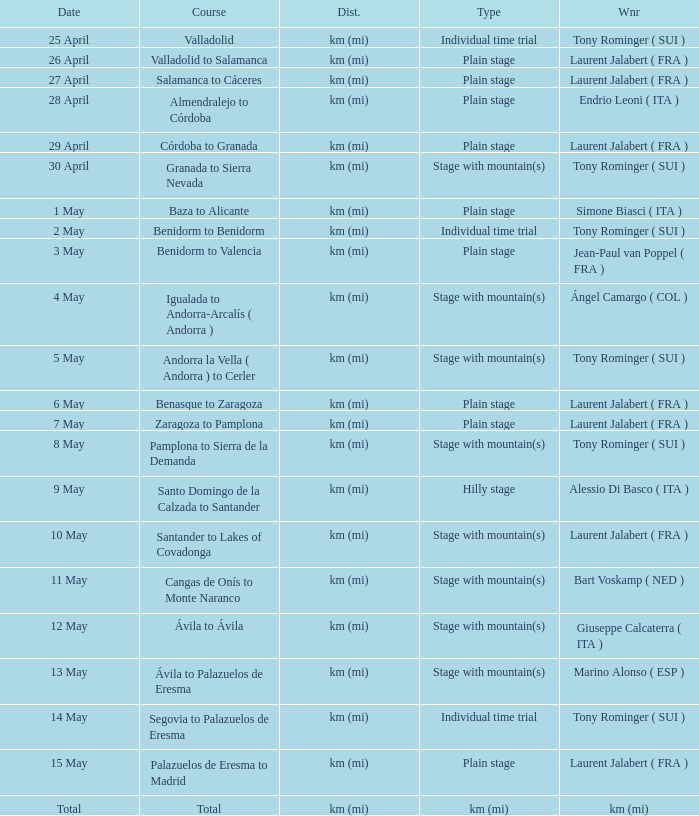What was the date with a winner of km (mi)? Total. 